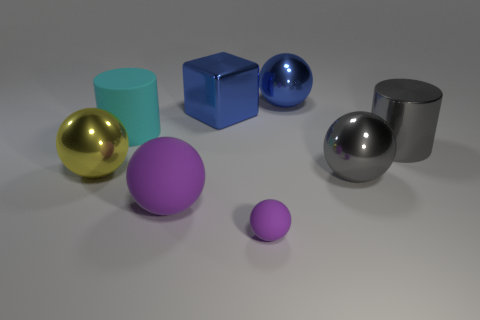Is there any other thing that has the same size as the blue block?
Provide a short and direct response. Yes. What number of purple rubber things have the same shape as the yellow metallic object?
Your response must be concise. 2. The large ball that is in front of the big cyan cylinder and on the right side of the block is made of what material?
Keep it short and to the point. Metal. There is a blue block; what number of objects are on the left side of it?
Your answer should be very brief. 3. How many large cyan rubber blocks are there?
Offer a very short reply. 0. Is the cyan matte cylinder the same size as the gray metallic cylinder?
Provide a short and direct response. Yes. There is a blue object in front of the large blue thing that is behind the blue cube; are there any purple matte spheres that are to the left of it?
Offer a very short reply. Yes. There is a large yellow object that is the same shape as the large purple rubber thing; what material is it?
Ensure brevity in your answer.  Metal. What is the color of the large ball that is in front of the gray sphere?
Your answer should be very brief. Purple. The cyan rubber cylinder has what size?
Make the answer very short. Large. 